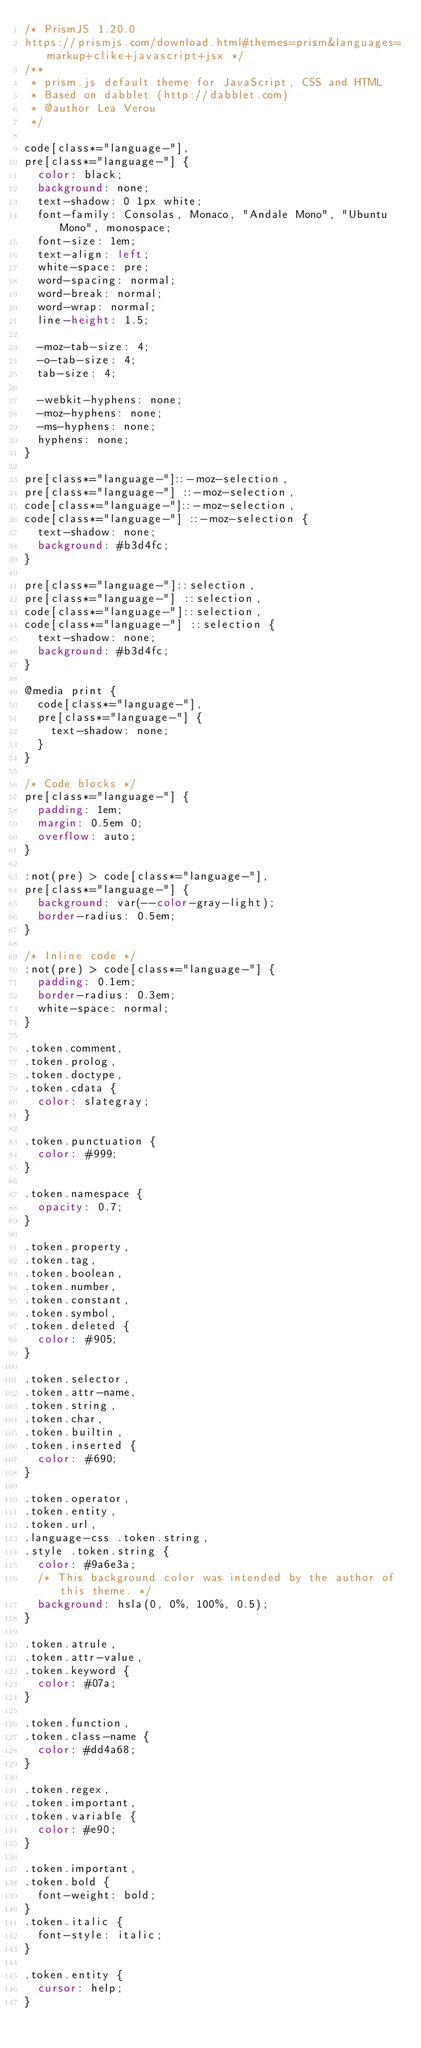<code> <loc_0><loc_0><loc_500><loc_500><_CSS_>/* PrismJS 1.20.0
https://prismjs.com/download.html#themes=prism&languages=markup+clike+javascript+jsx */
/**
 * prism.js default theme for JavaScript, CSS and HTML
 * Based on dabblet (http://dabblet.com)
 * @author Lea Verou
 */

code[class*="language-"],
pre[class*="language-"] {
  color: black;
  background: none;
  text-shadow: 0 1px white;
  font-family: Consolas, Monaco, "Andale Mono", "Ubuntu Mono", monospace;
  font-size: 1em;
  text-align: left;
  white-space: pre;
  word-spacing: normal;
  word-break: normal;
  word-wrap: normal;
  line-height: 1.5;

  -moz-tab-size: 4;
  -o-tab-size: 4;
  tab-size: 4;

  -webkit-hyphens: none;
  -moz-hyphens: none;
  -ms-hyphens: none;
  hyphens: none;
}

pre[class*="language-"]::-moz-selection,
pre[class*="language-"] ::-moz-selection,
code[class*="language-"]::-moz-selection,
code[class*="language-"] ::-moz-selection {
  text-shadow: none;
  background: #b3d4fc;
}

pre[class*="language-"]::selection,
pre[class*="language-"] ::selection,
code[class*="language-"]::selection,
code[class*="language-"] ::selection {
  text-shadow: none;
  background: #b3d4fc;
}

@media print {
  code[class*="language-"],
  pre[class*="language-"] {
    text-shadow: none;
  }
}

/* Code blocks */
pre[class*="language-"] {
  padding: 1em;
  margin: 0.5em 0;
  overflow: auto;
}

:not(pre) > code[class*="language-"],
pre[class*="language-"] {
  background: var(--color-gray-light);
  border-radius: 0.5em;
}

/* Inline code */
:not(pre) > code[class*="language-"] {
  padding: 0.1em;
  border-radius: 0.3em;
  white-space: normal;
}

.token.comment,
.token.prolog,
.token.doctype,
.token.cdata {
  color: slategray;
}

.token.punctuation {
  color: #999;
}

.token.namespace {
  opacity: 0.7;
}

.token.property,
.token.tag,
.token.boolean,
.token.number,
.token.constant,
.token.symbol,
.token.deleted {
  color: #905;
}

.token.selector,
.token.attr-name,
.token.string,
.token.char,
.token.builtin,
.token.inserted {
  color: #690;
}

.token.operator,
.token.entity,
.token.url,
.language-css .token.string,
.style .token.string {
  color: #9a6e3a;
  /* This background color was intended by the author of this theme. */
  background: hsla(0, 0%, 100%, 0.5);
}

.token.atrule,
.token.attr-value,
.token.keyword {
  color: #07a;
}

.token.function,
.token.class-name {
  color: #dd4a68;
}

.token.regex,
.token.important,
.token.variable {
  color: #e90;
}

.token.important,
.token.bold {
  font-weight: bold;
}
.token.italic {
  font-style: italic;
}

.token.entity {
  cursor: help;
}
</code> 